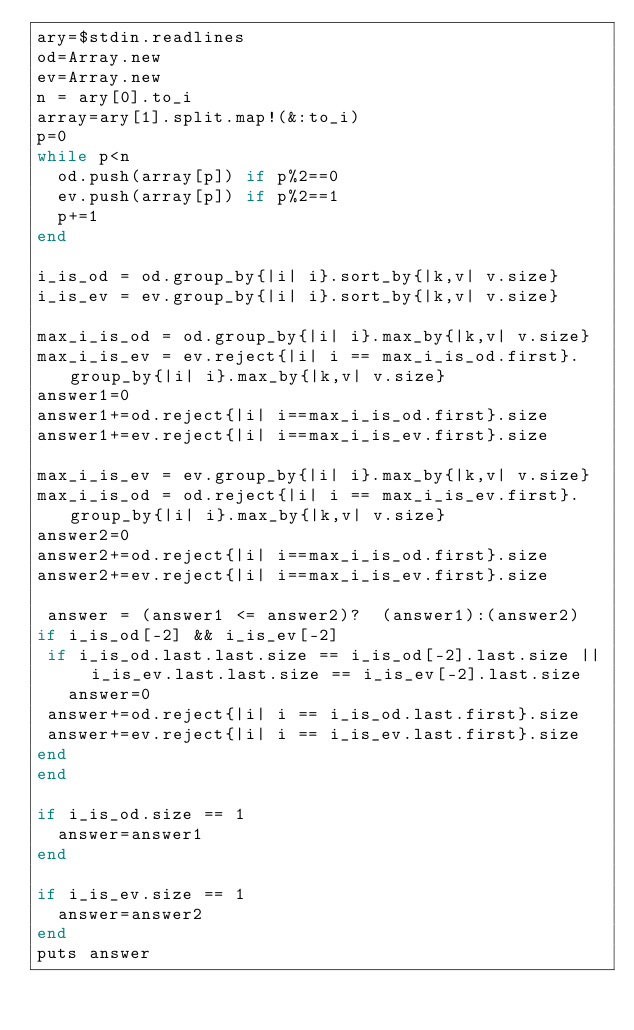Convert code to text. <code><loc_0><loc_0><loc_500><loc_500><_Ruby_>ary=$stdin.readlines
od=Array.new
ev=Array.new
n = ary[0].to_i
array=ary[1].split.map!(&:to_i)
p=0
while p<n
  od.push(array[p]) if p%2==0
  ev.push(array[p]) if p%2==1
  p+=1
end

i_is_od = od.group_by{|i| i}.sort_by{|k,v| v.size}
i_is_ev = ev.group_by{|i| i}.sort_by{|k,v| v.size}

max_i_is_od = od.group_by{|i| i}.max_by{|k,v| v.size}
max_i_is_ev = ev.reject{|i| i == max_i_is_od.first}.group_by{|i| i}.max_by{|k,v| v.size}
answer1=0
answer1+=od.reject{|i| i==max_i_is_od.first}.size
answer1+=ev.reject{|i| i==max_i_is_ev.first}.size

max_i_is_ev = ev.group_by{|i| i}.max_by{|k,v| v.size}
max_i_is_od = od.reject{|i| i == max_i_is_ev.first}.group_by{|i| i}.max_by{|k,v| v.size}
answer2=0
answer2+=od.reject{|i| i==max_i_is_od.first}.size
answer2+=ev.reject{|i| i==max_i_is_ev.first}.size

 answer = (answer1 <= answer2)?  (answer1):(answer2)
if i_is_od[-2] && i_is_ev[-2]
 if i_is_od.last.last.size == i_is_od[-2].last.size || i_is_ev.last.last.size == i_is_ev[-2].last.size
   answer=0
 answer+=od.reject{|i| i == i_is_od.last.first}.size
 answer+=ev.reject{|i| i == i_is_ev.last.first}.size
end
end

if i_is_od.size == 1
  answer=answer1
end

if i_is_ev.size == 1
  answer=answer2
end
puts answer</code> 